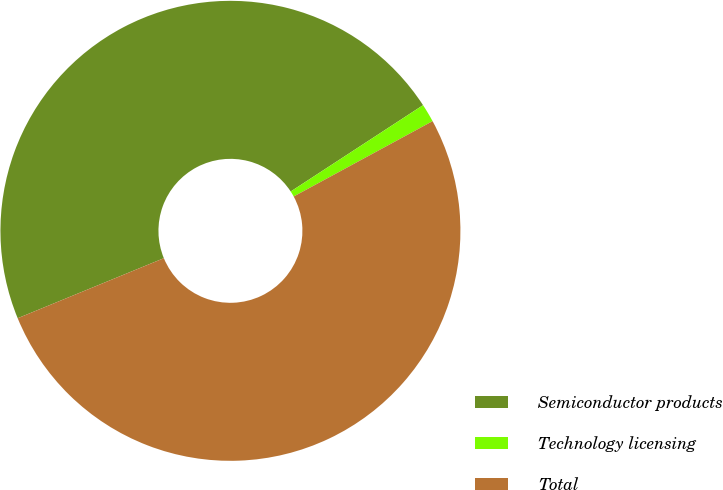<chart> <loc_0><loc_0><loc_500><loc_500><pie_chart><fcel>Semiconductor products<fcel>Technology licensing<fcel>Total<nl><fcel>47.0%<fcel>1.29%<fcel>51.7%<nl></chart> 